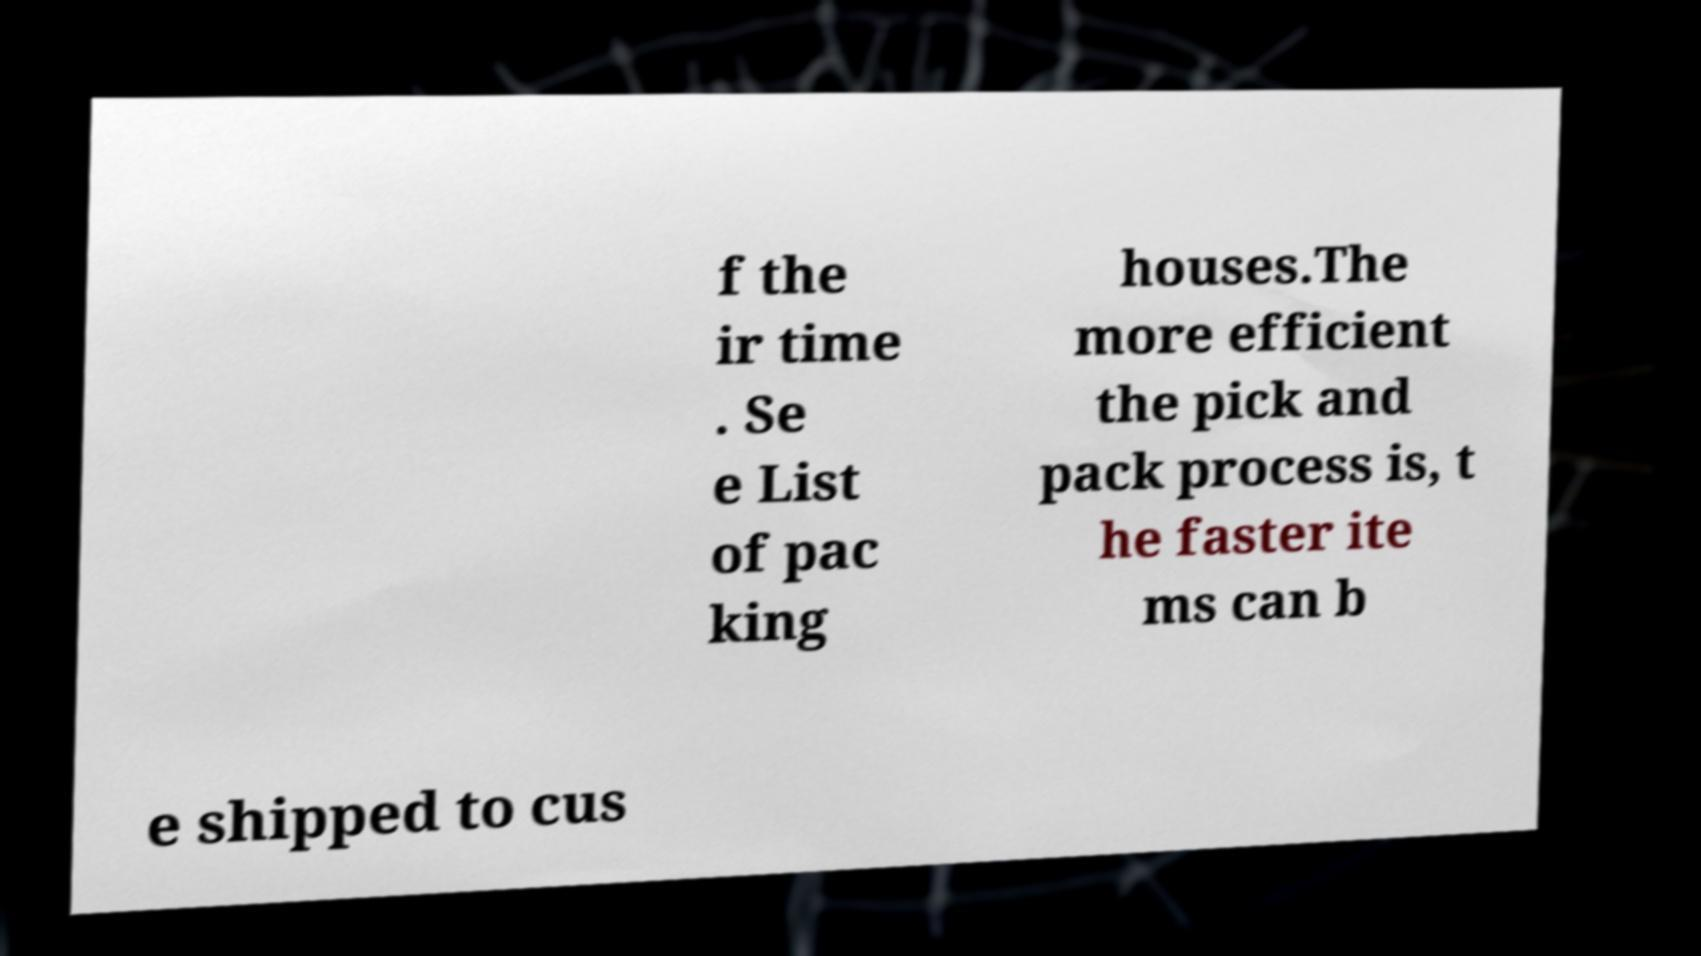Could you assist in decoding the text presented in this image and type it out clearly? f the ir time . Se e List of pac king houses.The more efficient the pick and pack process is, t he faster ite ms can b e shipped to cus 